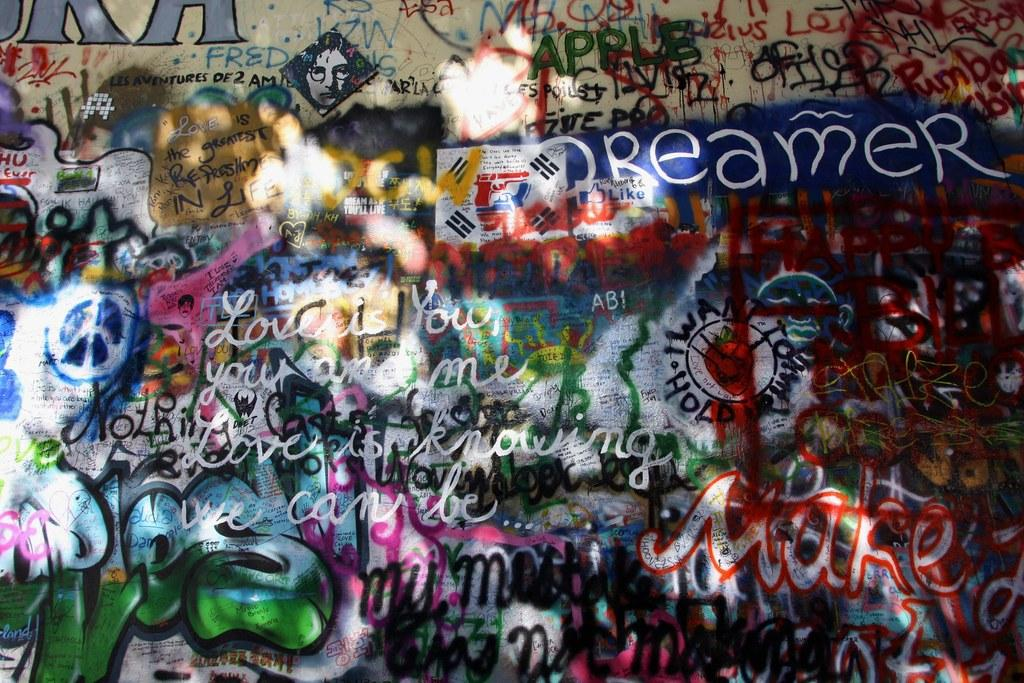What type of wall is depicted in the image? There is a spray paint wall in the image. What type of oatmeal is being served on the bridge in the image? There is no oatmeal or bridge present in the image; it features a spray paint wall. What type of business is being conducted on the spray paint wall in the image? The image does not depict any business activities; it simply shows a spray paint wall. 